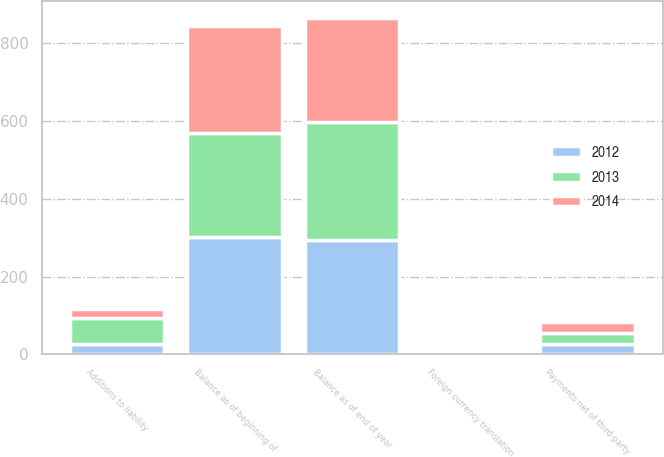Convert chart. <chart><loc_0><loc_0><loc_500><loc_500><stacked_bar_chart><ecel><fcel>Balance as of beginning of<fcel>Additions to liability<fcel>Payments net of third-party<fcel>Foreign currency translation<fcel>Balance as of end of year<nl><fcel>2012<fcel>301<fcel>26<fcel>27<fcel>5<fcel>295<nl><fcel>2013<fcel>269<fcel>67<fcel>28<fcel>2<fcel>301<nl><fcel>2014<fcel>274<fcel>23<fcel>29<fcel>2<fcel>269<nl></chart> 